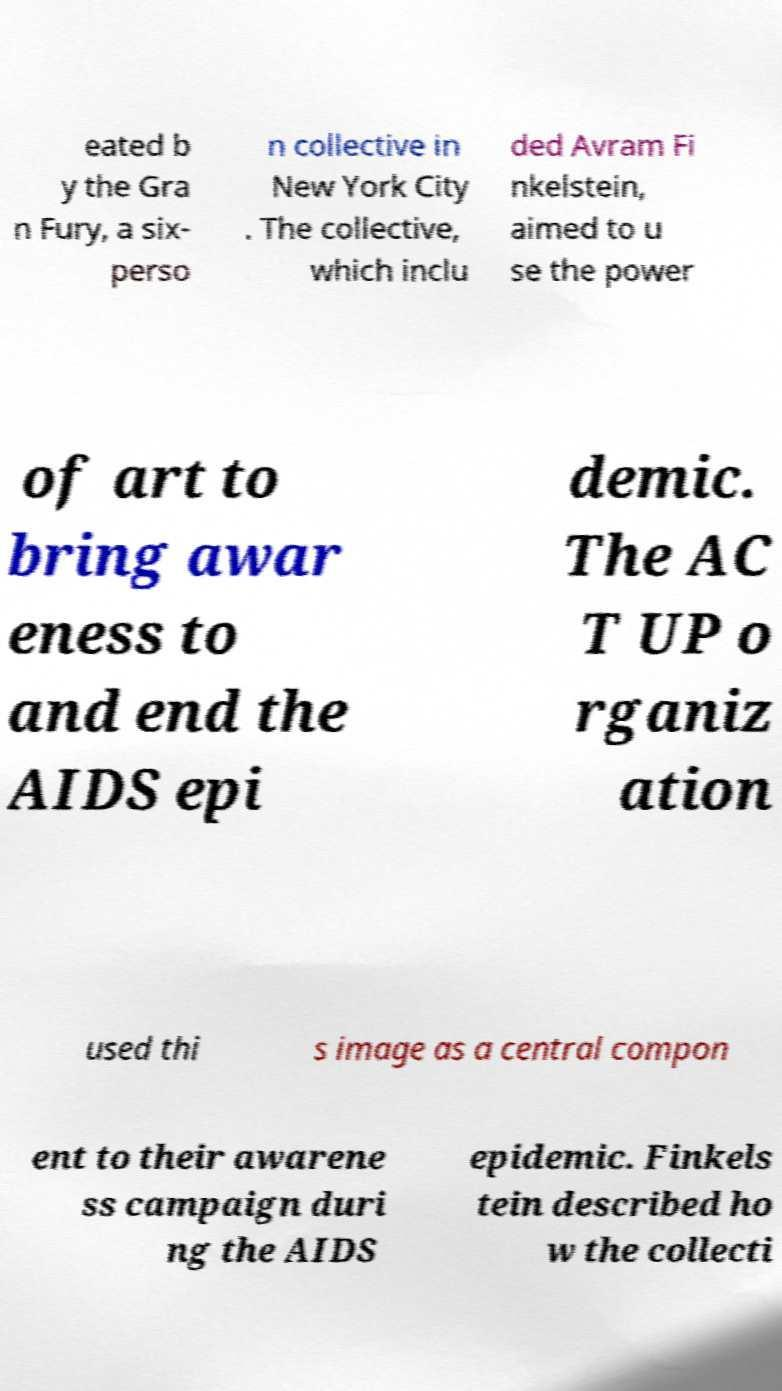Please read and relay the text visible in this image. What does it say? eated b y the Gra n Fury, a six- perso n collective in New York City . The collective, which inclu ded Avram Fi nkelstein, aimed to u se the power of art to bring awar eness to and end the AIDS epi demic. The AC T UP o rganiz ation used thi s image as a central compon ent to their awarene ss campaign duri ng the AIDS epidemic. Finkels tein described ho w the collecti 